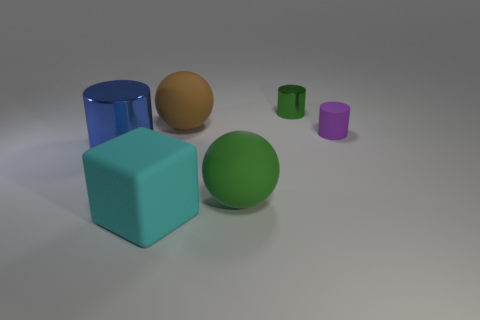Add 1 big blocks. How many objects exist? 7 Subtract all blue cylinders. How many cylinders are left? 2 Subtract all purple cylinders. How many cylinders are left? 2 Subtract 1 green spheres. How many objects are left? 5 Subtract all balls. How many objects are left? 4 Subtract all blue cubes. Subtract all blue cylinders. How many cubes are left? 1 Subtract all yellow spheres. How many purple cylinders are left? 1 Subtract all small green cubes. Subtract all small cylinders. How many objects are left? 4 Add 1 green objects. How many green objects are left? 3 Add 3 green shiny things. How many green shiny things exist? 4 